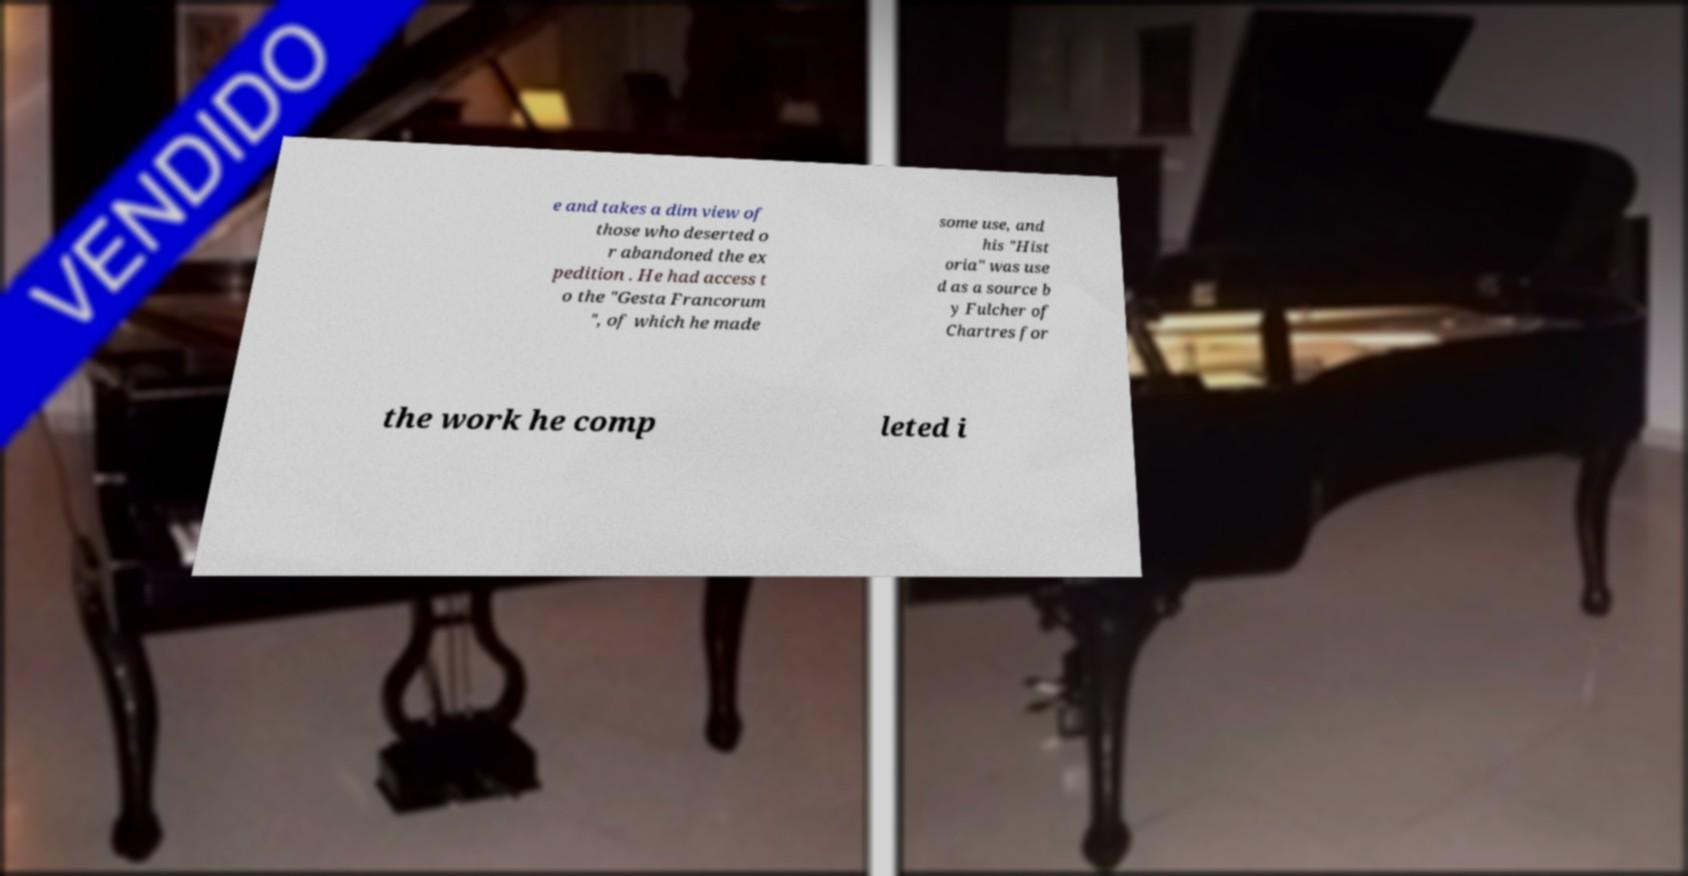I need the written content from this picture converted into text. Can you do that? e and takes a dim view of those who deserted o r abandoned the ex pedition . He had access t o the "Gesta Francorum ", of which he made some use, and his "Hist oria" was use d as a source b y Fulcher of Chartres for the work he comp leted i 